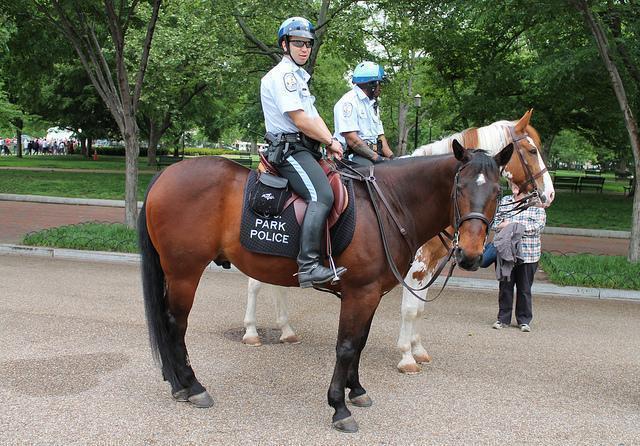Where are these policemen patrolling?
Pick the right solution, then justify: 'Answer: answer
Rationale: rationale.'
Options: Inside park, at airport, in city, tourist zone. Answer: inside park.
Rationale: They are on patrol in a local park 